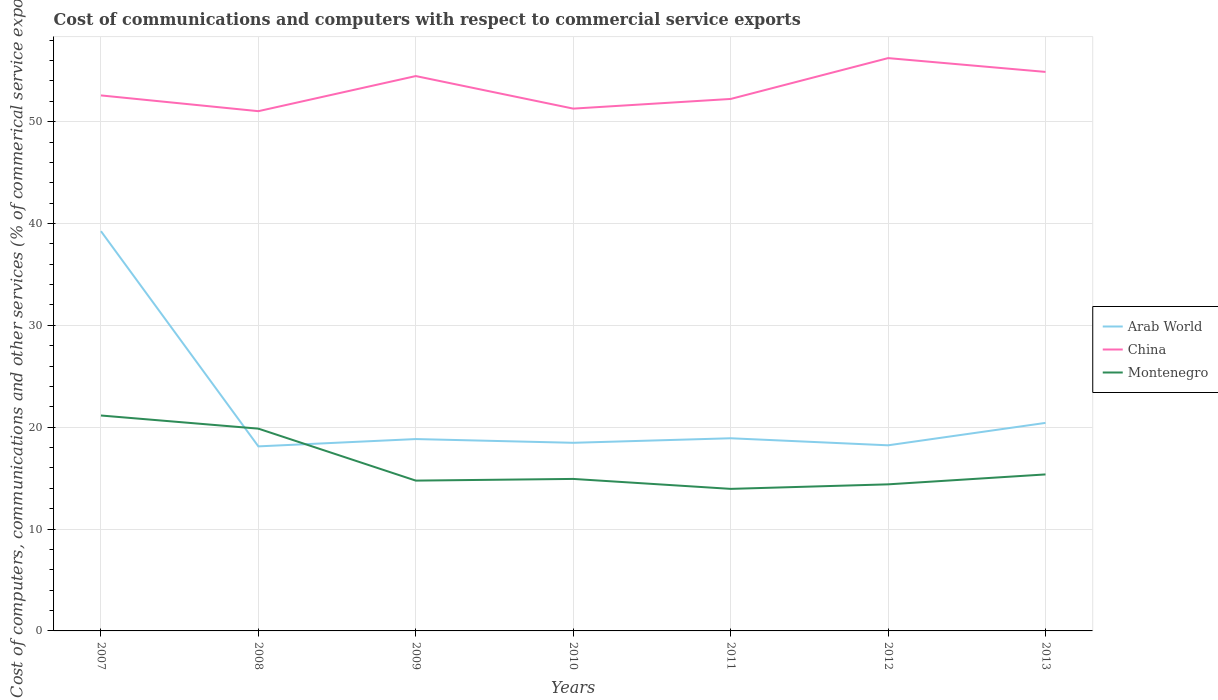Does the line corresponding to Arab World intersect with the line corresponding to China?
Ensure brevity in your answer.  No. Is the number of lines equal to the number of legend labels?
Make the answer very short. Yes. Across all years, what is the maximum cost of communications and computers in Arab World?
Your answer should be compact. 18.12. In which year was the cost of communications and computers in Montenegro maximum?
Your response must be concise. 2011. What is the total cost of communications and computers in China in the graph?
Offer a very short reply. 1.55. What is the difference between the highest and the second highest cost of communications and computers in Montenegro?
Give a very brief answer. 7.2. Is the cost of communications and computers in Montenegro strictly greater than the cost of communications and computers in China over the years?
Offer a terse response. Yes. How many years are there in the graph?
Provide a short and direct response. 7. Does the graph contain grids?
Ensure brevity in your answer.  Yes. Where does the legend appear in the graph?
Ensure brevity in your answer.  Center right. What is the title of the graph?
Give a very brief answer. Cost of communications and computers with respect to commercial service exports. Does "North America" appear as one of the legend labels in the graph?
Ensure brevity in your answer.  No. What is the label or title of the X-axis?
Offer a very short reply. Years. What is the label or title of the Y-axis?
Offer a terse response. Cost of computers, communications and other services (% of commerical service exports). What is the Cost of computers, communications and other services (% of commerical service exports) in Arab World in 2007?
Ensure brevity in your answer.  39.25. What is the Cost of computers, communications and other services (% of commerical service exports) of China in 2007?
Offer a very short reply. 52.58. What is the Cost of computers, communications and other services (% of commerical service exports) in Montenegro in 2007?
Give a very brief answer. 21.15. What is the Cost of computers, communications and other services (% of commerical service exports) of Arab World in 2008?
Provide a short and direct response. 18.12. What is the Cost of computers, communications and other services (% of commerical service exports) of China in 2008?
Your answer should be very brief. 51.03. What is the Cost of computers, communications and other services (% of commerical service exports) in Montenegro in 2008?
Ensure brevity in your answer.  19.86. What is the Cost of computers, communications and other services (% of commerical service exports) in Arab World in 2009?
Your response must be concise. 18.84. What is the Cost of computers, communications and other services (% of commerical service exports) of China in 2009?
Offer a very short reply. 54.48. What is the Cost of computers, communications and other services (% of commerical service exports) of Montenegro in 2009?
Provide a short and direct response. 14.76. What is the Cost of computers, communications and other services (% of commerical service exports) of Arab World in 2010?
Offer a terse response. 18.47. What is the Cost of computers, communications and other services (% of commerical service exports) of China in 2010?
Your answer should be very brief. 51.28. What is the Cost of computers, communications and other services (% of commerical service exports) in Montenegro in 2010?
Your answer should be very brief. 14.92. What is the Cost of computers, communications and other services (% of commerical service exports) in Arab World in 2011?
Provide a short and direct response. 18.92. What is the Cost of computers, communications and other services (% of commerical service exports) of China in 2011?
Offer a very short reply. 52.23. What is the Cost of computers, communications and other services (% of commerical service exports) in Montenegro in 2011?
Give a very brief answer. 13.95. What is the Cost of computers, communications and other services (% of commerical service exports) in Arab World in 2012?
Your response must be concise. 18.22. What is the Cost of computers, communications and other services (% of commerical service exports) in China in 2012?
Provide a succinct answer. 56.24. What is the Cost of computers, communications and other services (% of commerical service exports) in Montenegro in 2012?
Ensure brevity in your answer.  14.39. What is the Cost of computers, communications and other services (% of commerical service exports) in Arab World in 2013?
Your response must be concise. 20.43. What is the Cost of computers, communications and other services (% of commerical service exports) of China in 2013?
Offer a very short reply. 54.89. What is the Cost of computers, communications and other services (% of commerical service exports) in Montenegro in 2013?
Offer a terse response. 15.37. Across all years, what is the maximum Cost of computers, communications and other services (% of commerical service exports) of Arab World?
Offer a terse response. 39.25. Across all years, what is the maximum Cost of computers, communications and other services (% of commerical service exports) in China?
Your answer should be very brief. 56.24. Across all years, what is the maximum Cost of computers, communications and other services (% of commerical service exports) of Montenegro?
Provide a short and direct response. 21.15. Across all years, what is the minimum Cost of computers, communications and other services (% of commerical service exports) of Arab World?
Keep it short and to the point. 18.12. Across all years, what is the minimum Cost of computers, communications and other services (% of commerical service exports) in China?
Your answer should be very brief. 51.03. Across all years, what is the minimum Cost of computers, communications and other services (% of commerical service exports) in Montenegro?
Your response must be concise. 13.95. What is the total Cost of computers, communications and other services (% of commerical service exports) of Arab World in the graph?
Make the answer very short. 152.24. What is the total Cost of computers, communications and other services (% of commerical service exports) of China in the graph?
Your answer should be very brief. 372.72. What is the total Cost of computers, communications and other services (% of commerical service exports) in Montenegro in the graph?
Make the answer very short. 114.4. What is the difference between the Cost of computers, communications and other services (% of commerical service exports) in Arab World in 2007 and that in 2008?
Provide a short and direct response. 21.13. What is the difference between the Cost of computers, communications and other services (% of commerical service exports) in China in 2007 and that in 2008?
Your answer should be compact. 1.55. What is the difference between the Cost of computers, communications and other services (% of commerical service exports) in Montenegro in 2007 and that in 2008?
Your response must be concise. 1.29. What is the difference between the Cost of computers, communications and other services (% of commerical service exports) in Arab World in 2007 and that in 2009?
Offer a very short reply. 20.41. What is the difference between the Cost of computers, communications and other services (% of commerical service exports) in China in 2007 and that in 2009?
Offer a terse response. -1.9. What is the difference between the Cost of computers, communications and other services (% of commerical service exports) in Montenegro in 2007 and that in 2009?
Your answer should be compact. 6.39. What is the difference between the Cost of computers, communications and other services (% of commerical service exports) of Arab World in 2007 and that in 2010?
Make the answer very short. 20.78. What is the difference between the Cost of computers, communications and other services (% of commerical service exports) in China in 2007 and that in 2010?
Your answer should be very brief. 1.3. What is the difference between the Cost of computers, communications and other services (% of commerical service exports) of Montenegro in 2007 and that in 2010?
Offer a very short reply. 6.23. What is the difference between the Cost of computers, communications and other services (% of commerical service exports) of Arab World in 2007 and that in 2011?
Ensure brevity in your answer.  20.33. What is the difference between the Cost of computers, communications and other services (% of commerical service exports) in China in 2007 and that in 2011?
Offer a terse response. 0.35. What is the difference between the Cost of computers, communications and other services (% of commerical service exports) in Montenegro in 2007 and that in 2011?
Offer a very short reply. 7.2. What is the difference between the Cost of computers, communications and other services (% of commerical service exports) of Arab World in 2007 and that in 2012?
Make the answer very short. 21.03. What is the difference between the Cost of computers, communications and other services (% of commerical service exports) of China in 2007 and that in 2012?
Provide a short and direct response. -3.66. What is the difference between the Cost of computers, communications and other services (% of commerical service exports) in Montenegro in 2007 and that in 2012?
Provide a succinct answer. 6.76. What is the difference between the Cost of computers, communications and other services (% of commerical service exports) in Arab World in 2007 and that in 2013?
Your answer should be very brief. 18.82. What is the difference between the Cost of computers, communications and other services (% of commerical service exports) in China in 2007 and that in 2013?
Keep it short and to the point. -2.31. What is the difference between the Cost of computers, communications and other services (% of commerical service exports) in Montenegro in 2007 and that in 2013?
Offer a terse response. 5.78. What is the difference between the Cost of computers, communications and other services (% of commerical service exports) in Arab World in 2008 and that in 2009?
Offer a terse response. -0.72. What is the difference between the Cost of computers, communications and other services (% of commerical service exports) in China in 2008 and that in 2009?
Offer a very short reply. -3.45. What is the difference between the Cost of computers, communications and other services (% of commerical service exports) in Montenegro in 2008 and that in 2009?
Your answer should be compact. 5.1. What is the difference between the Cost of computers, communications and other services (% of commerical service exports) of Arab World in 2008 and that in 2010?
Your answer should be compact. -0.35. What is the difference between the Cost of computers, communications and other services (% of commerical service exports) in China in 2008 and that in 2010?
Offer a terse response. -0.25. What is the difference between the Cost of computers, communications and other services (% of commerical service exports) in Montenegro in 2008 and that in 2010?
Provide a succinct answer. 4.94. What is the difference between the Cost of computers, communications and other services (% of commerical service exports) of Arab World in 2008 and that in 2011?
Give a very brief answer. -0.8. What is the difference between the Cost of computers, communications and other services (% of commerical service exports) in China in 2008 and that in 2011?
Offer a very short reply. -1.2. What is the difference between the Cost of computers, communications and other services (% of commerical service exports) in Montenegro in 2008 and that in 2011?
Your answer should be very brief. 5.91. What is the difference between the Cost of computers, communications and other services (% of commerical service exports) of Arab World in 2008 and that in 2012?
Keep it short and to the point. -0.11. What is the difference between the Cost of computers, communications and other services (% of commerical service exports) of China in 2008 and that in 2012?
Make the answer very short. -5.21. What is the difference between the Cost of computers, communications and other services (% of commerical service exports) in Montenegro in 2008 and that in 2012?
Provide a succinct answer. 5.47. What is the difference between the Cost of computers, communications and other services (% of commerical service exports) in Arab World in 2008 and that in 2013?
Offer a very short reply. -2.31. What is the difference between the Cost of computers, communications and other services (% of commerical service exports) in China in 2008 and that in 2013?
Your answer should be compact. -3.85. What is the difference between the Cost of computers, communications and other services (% of commerical service exports) in Montenegro in 2008 and that in 2013?
Your answer should be compact. 4.49. What is the difference between the Cost of computers, communications and other services (% of commerical service exports) of Arab World in 2009 and that in 2010?
Give a very brief answer. 0.37. What is the difference between the Cost of computers, communications and other services (% of commerical service exports) in China in 2009 and that in 2010?
Ensure brevity in your answer.  3.2. What is the difference between the Cost of computers, communications and other services (% of commerical service exports) of Montenegro in 2009 and that in 2010?
Your answer should be compact. -0.17. What is the difference between the Cost of computers, communications and other services (% of commerical service exports) in Arab World in 2009 and that in 2011?
Keep it short and to the point. -0.08. What is the difference between the Cost of computers, communications and other services (% of commerical service exports) of China in 2009 and that in 2011?
Keep it short and to the point. 2.25. What is the difference between the Cost of computers, communications and other services (% of commerical service exports) in Montenegro in 2009 and that in 2011?
Provide a short and direct response. 0.81. What is the difference between the Cost of computers, communications and other services (% of commerical service exports) of Arab World in 2009 and that in 2012?
Ensure brevity in your answer.  0.61. What is the difference between the Cost of computers, communications and other services (% of commerical service exports) of China in 2009 and that in 2012?
Your answer should be compact. -1.76. What is the difference between the Cost of computers, communications and other services (% of commerical service exports) of Montenegro in 2009 and that in 2012?
Ensure brevity in your answer.  0.37. What is the difference between the Cost of computers, communications and other services (% of commerical service exports) in Arab World in 2009 and that in 2013?
Provide a succinct answer. -1.59. What is the difference between the Cost of computers, communications and other services (% of commerical service exports) in China in 2009 and that in 2013?
Provide a short and direct response. -0.41. What is the difference between the Cost of computers, communications and other services (% of commerical service exports) in Montenegro in 2009 and that in 2013?
Provide a succinct answer. -0.61. What is the difference between the Cost of computers, communications and other services (% of commerical service exports) of Arab World in 2010 and that in 2011?
Make the answer very short. -0.44. What is the difference between the Cost of computers, communications and other services (% of commerical service exports) in China in 2010 and that in 2011?
Keep it short and to the point. -0.95. What is the difference between the Cost of computers, communications and other services (% of commerical service exports) in Montenegro in 2010 and that in 2011?
Give a very brief answer. 0.98. What is the difference between the Cost of computers, communications and other services (% of commerical service exports) of Arab World in 2010 and that in 2012?
Offer a very short reply. 0.25. What is the difference between the Cost of computers, communications and other services (% of commerical service exports) in China in 2010 and that in 2012?
Your answer should be compact. -4.96. What is the difference between the Cost of computers, communications and other services (% of commerical service exports) of Montenegro in 2010 and that in 2012?
Your answer should be very brief. 0.53. What is the difference between the Cost of computers, communications and other services (% of commerical service exports) in Arab World in 2010 and that in 2013?
Your answer should be compact. -1.95. What is the difference between the Cost of computers, communications and other services (% of commerical service exports) in China in 2010 and that in 2013?
Offer a very short reply. -3.6. What is the difference between the Cost of computers, communications and other services (% of commerical service exports) in Montenegro in 2010 and that in 2013?
Your answer should be compact. -0.44. What is the difference between the Cost of computers, communications and other services (% of commerical service exports) in Arab World in 2011 and that in 2012?
Offer a very short reply. 0.69. What is the difference between the Cost of computers, communications and other services (% of commerical service exports) of China in 2011 and that in 2012?
Provide a succinct answer. -4.01. What is the difference between the Cost of computers, communications and other services (% of commerical service exports) in Montenegro in 2011 and that in 2012?
Your response must be concise. -0.44. What is the difference between the Cost of computers, communications and other services (% of commerical service exports) of Arab World in 2011 and that in 2013?
Offer a very short reply. -1.51. What is the difference between the Cost of computers, communications and other services (% of commerical service exports) in China in 2011 and that in 2013?
Ensure brevity in your answer.  -2.65. What is the difference between the Cost of computers, communications and other services (% of commerical service exports) in Montenegro in 2011 and that in 2013?
Keep it short and to the point. -1.42. What is the difference between the Cost of computers, communications and other services (% of commerical service exports) of Arab World in 2012 and that in 2013?
Your answer should be compact. -2.2. What is the difference between the Cost of computers, communications and other services (% of commerical service exports) in China in 2012 and that in 2013?
Your answer should be compact. 1.35. What is the difference between the Cost of computers, communications and other services (% of commerical service exports) in Montenegro in 2012 and that in 2013?
Ensure brevity in your answer.  -0.97. What is the difference between the Cost of computers, communications and other services (% of commerical service exports) in Arab World in 2007 and the Cost of computers, communications and other services (% of commerical service exports) in China in 2008?
Offer a terse response. -11.78. What is the difference between the Cost of computers, communications and other services (% of commerical service exports) in Arab World in 2007 and the Cost of computers, communications and other services (% of commerical service exports) in Montenegro in 2008?
Your answer should be compact. 19.39. What is the difference between the Cost of computers, communications and other services (% of commerical service exports) of China in 2007 and the Cost of computers, communications and other services (% of commerical service exports) of Montenegro in 2008?
Offer a terse response. 32.72. What is the difference between the Cost of computers, communications and other services (% of commerical service exports) of Arab World in 2007 and the Cost of computers, communications and other services (% of commerical service exports) of China in 2009?
Your answer should be compact. -15.23. What is the difference between the Cost of computers, communications and other services (% of commerical service exports) of Arab World in 2007 and the Cost of computers, communications and other services (% of commerical service exports) of Montenegro in 2009?
Your answer should be very brief. 24.49. What is the difference between the Cost of computers, communications and other services (% of commerical service exports) in China in 2007 and the Cost of computers, communications and other services (% of commerical service exports) in Montenegro in 2009?
Your response must be concise. 37.82. What is the difference between the Cost of computers, communications and other services (% of commerical service exports) of Arab World in 2007 and the Cost of computers, communications and other services (% of commerical service exports) of China in 2010?
Offer a very short reply. -12.03. What is the difference between the Cost of computers, communications and other services (% of commerical service exports) of Arab World in 2007 and the Cost of computers, communications and other services (% of commerical service exports) of Montenegro in 2010?
Give a very brief answer. 24.33. What is the difference between the Cost of computers, communications and other services (% of commerical service exports) of China in 2007 and the Cost of computers, communications and other services (% of commerical service exports) of Montenegro in 2010?
Provide a short and direct response. 37.65. What is the difference between the Cost of computers, communications and other services (% of commerical service exports) of Arab World in 2007 and the Cost of computers, communications and other services (% of commerical service exports) of China in 2011?
Provide a succinct answer. -12.98. What is the difference between the Cost of computers, communications and other services (% of commerical service exports) of Arab World in 2007 and the Cost of computers, communications and other services (% of commerical service exports) of Montenegro in 2011?
Give a very brief answer. 25.3. What is the difference between the Cost of computers, communications and other services (% of commerical service exports) in China in 2007 and the Cost of computers, communications and other services (% of commerical service exports) in Montenegro in 2011?
Your answer should be very brief. 38.63. What is the difference between the Cost of computers, communications and other services (% of commerical service exports) in Arab World in 2007 and the Cost of computers, communications and other services (% of commerical service exports) in China in 2012?
Ensure brevity in your answer.  -16.99. What is the difference between the Cost of computers, communications and other services (% of commerical service exports) in Arab World in 2007 and the Cost of computers, communications and other services (% of commerical service exports) in Montenegro in 2012?
Provide a succinct answer. 24.86. What is the difference between the Cost of computers, communications and other services (% of commerical service exports) of China in 2007 and the Cost of computers, communications and other services (% of commerical service exports) of Montenegro in 2012?
Keep it short and to the point. 38.19. What is the difference between the Cost of computers, communications and other services (% of commerical service exports) in Arab World in 2007 and the Cost of computers, communications and other services (% of commerical service exports) in China in 2013?
Your answer should be very brief. -15.64. What is the difference between the Cost of computers, communications and other services (% of commerical service exports) of Arab World in 2007 and the Cost of computers, communications and other services (% of commerical service exports) of Montenegro in 2013?
Ensure brevity in your answer.  23.88. What is the difference between the Cost of computers, communications and other services (% of commerical service exports) in China in 2007 and the Cost of computers, communications and other services (% of commerical service exports) in Montenegro in 2013?
Provide a succinct answer. 37.21. What is the difference between the Cost of computers, communications and other services (% of commerical service exports) in Arab World in 2008 and the Cost of computers, communications and other services (% of commerical service exports) in China in 2009?
Offer a terse response. -36.36. What is the difference between the Cost of computers, communications and other services (% of commerical service exports) in Arab World in 2008 and the Cost of computers, communications and other services (% of commerical service exports) in Montenegro in 2009?
Make the answer very short. 3.36. What is the difference between the Cost of computers, communications and other services (% of commerical service exports) of China in 2008 and the Cost of computers, communications and other services (% of commerical service exports) of Montenegro in 2009?
Keep it short and to the point. 36.27. What is the difference between the Cost of computers, communications and other services (% of commerical service exports) of Arab World in 2008 and the Cost of computers, communications and other services (% of commerical service exports) of China in 2010?
Offer a very short reply. -33.16. What is the difference between the Cost of computers, communications and other services (% of commerical service exports) in Arab World in 2008 and the Cost of computers, communications and other services (% of commerical service exports) in Montenegro in 2010?
Give a very brief answer. 3.2. What is the difference between the Cost of computers, communications and other services (% of commerical service exports) of China in 2008 and the Cost of computers, communications and other services (% of commerical service exports) of Montenegro in 2010?
Provide a short and direct response. 36.11. What is the difference between the Cost of computers, communications and other services (% of commerical service exports) of Arab World in 2008 and the Cost of computers, communications and other services (% of commerical service exports) of China in 2011?
Your answer should be very brief. -34.11. What is the difference between the Cost of computers, communications and other services (% of commerical service exports) of Arab World in 2008 and the Cost of computers, communications and other services (% of commerical service exports) of Montenegro in 2011?
Your response must be concise. 4.17. What is the difference between the Cost of computers, communications and other services (% of commerical service exports) of China in 2008 and the Cost of computers, communications and other services (% of commerical service exports) of Montenegro in 2011?
Your response must be concise. 37.08. What is the difference between the Cost of computers, communications and other services (% of commerical service exports) of Arab World in 2008 and the Cost of computers, communications and other services (% of commerical service exports) of China in 2012?
Keep it short and to the point. -38.12. What is the difference between the Cost of computers, communications and other services (% of commerical service exports) in Arab World in 2008 and the Cost of computers, communications and other services (% of commerical service exports) in Montenegro in 2012?
Your answer should be very brief. 3.73. What is the difference between the Cost of computers, communications and other services (% of commerical service exports) of China in 2008 and the Cost of computers, communications and other services (% of commerical service exports) of Montenegro in 2012?
Your answer should be compact. 36.64. What is the difference between the Cost of computers, communications and other services (% of commerical service exports) of Arab World in 2008 and the Cost of computers, communications and other services (% of commerical service exports) of China in 2013?
Provide a short and direct response. -36.77. What is the difference between the Cost of computers, communications and other services (% of commerical service exports) of Arab World in 2008 and the Cost of computers, communications and other services (% of commerical service exports) of Montenegro in 2013?
Your answer should be very brief. 2.75. What is the difference between the Cost of computers, communications and other services (% of commerical service exports) of China in 2008 and the Cost of computers, communications and other services (% of commerical service exports) of Montenegro in 2013?
Offer a terse response. 35.66. What is the difference between the Cost of computers, communications and other services (% of commerical service exports) of Arab World in 2009 and the Cost of computers, communications and other services (% of commerical service exports) of China in 2010?
Ensure brevity in your answer.  -32.44. What is the difference between the Cost of computers, communications and other services (% of commerical service exports) of Arab World in 2009 and the Cost of computers, communications and other services (% of commerical service exports) of Montenegro in 2010?
Your answer should be compact. 3.91. What is the difference between the Cost of computers, communications and other services (% of commerical service exports) in China in 2009 and the Cost of computers, communications and other services (% of commerical service exports) in Montenegro in 2010?
Offer a very short reply. 39.55. What is the difference between the Cost of computers, communications and other services (% of commerical service exports) of Arab World in 2009 and the Cost of computers, communications and other services (% of commerical service exports) of China in 2011?
Your answer should be very brief. -33.39. What is the difference between the Cost of computers, communications and other services (% of commerical service exports) in Arab World in 2009 and the Cost of computers, communications and other services (% of commerical service exports) in Montenegro in 2011?
Provide a succinct answer. 4.89. What is the difference between the Cost of computers, communications and other services (% of commerical service exports) of China in 2009 and the Cost of computers, communications and other services (% of commerical service exports) of Montenegro in 2011?
Make the answer very short. 40.53. What is the difference between the Cost of computers, communications and other services (% of commerical service exports) in Arab World in 2009 and the Cost of computers, communications and other services (% of commerical service exports) in China in 2012?
Provide a succinct answer. -37.4. What is the difference between the Cost of computers, communications and other services (% of commerical service exports) in Arab World in 2009 and the Cost of computers, communications and other services (% of commerical service exports) in Montenegro in 2012?
Ensure brevity in your answer.  4.45. What is the difference between the Cost of computers, communications and other services (% of commerical service exports) of China in 2009 and the Cost of computers, communications and other services (% of commerical service exports) of Montenegro in 2012?
Offer a terse response. 40.09. What is the difference between the Cost of computers, communications and other services (% of commerical service exports) in Arab World in 2009 and the Cost of computers, communications and other services (% of commerical service exports) in China in 2013?
Offer a very short reply. -36.05. What is the difference between the Cost of computers, communications and other services (% of commerical service exports) of Arab World in 2009 and the Cost of computers, communications and other services (% of commerical service exports) of Montenegro in 2013?
Provide a succinct answer. 3.47. What is the difference between the Cost of computers, communications and other services (% of commerical service exports) of China in 2009 and the Cost of computers, communications and other services (% of commerical service exports) of Montenegro in 2013?
Offer a very short reply. 39.11. What is the difference between the Cost of computers, communications and other services (% of commerical service exports) of Arab World in 2010 and the Cost of computers, communications and other services (% of commerical service exports) of China in 2011?
Provide a succinct answer. -33.76. What is the difference between the Cost of computers, communications and other services (% of commerical service exports) of Arab World in 2010 and the Cost of computers, communications and other services (% of commerical service exports) of Montenegro in 2011?
Your answer should be compact. 4.52. What is the difference between the Cost of computers, communications and other services (% of commerical service exports) in China in 2010 and the Cost of computers, communications and other services (% of commerical service exports) in Montenegro in 2011?
Give a very brief answer. 37.33. What is the difference between the Cost of computers, communications and other services (% of commerical service exports) in Arab World in 2010 and the Cost of computers, communications and other services (% of commerical service exports) in China in 2012?
Provide a short and direct response. -37.77. What is the difference between the Cost of computers, communications and other services (% of commerical service exports) in Arab World in 2010 and the Cost of computers, communications and other services (% of commerical service exports) in Montenegro in 2012?
Offer a very short reply. 4.08. What is the difference between the Cost of computers, communications and other services (% of commerical service exports) in China in 2010 and the Cost of computers, communications and other services (% of commerical service exports) in Montenegro in 2012?
Your response must be concise. 36.89. What is the difference between the Cost of computers, communications and other services (% of commerical service exports) of Arab World in 2010 and the Cost of computers, communications and other services (% of commerical service exports) of China in 2013?
Your response must be concise. -36.41. What is the difference between the Cost of computers, communications and other services (% of commerical service exports) in Arab World in 2010 and the Cost of computers, communications and other services (% of commerical service exports) in Montenegro in 2013?
Give a very brief answer. 3.1. What is the difference between the Cost of computers, communications and other services (% of commerical service exports) in China in 2010 and the Cost of computers, communications and other services (% of commerical service exports) in Montenegro in 2013?
Offer a terse response. 35.92. What is the difference between the Cost of computers, communications and other services (% of commerical service exports) in Arab World in 2011 and the Cost of computers, communications and other services (% of commerical service exports) in China in 2012?
Give a very brief answer. -37.32. What is the difference between the Cost of computers, communications and other services (% of commerical service exports) of Arab World in 2011 and the Cost of computers, communications and other services (% of commerical service exports) of Montenegro in 2012?
Your answer should be compact. 4.52. What is the difference between the Cost of computers, communications and other services (% of commerical service exports) in China in 2011 and the Cost of computers, communications and other services (% of commerical service exports) in Montenegro in 2012?
Keep it short and to the point. 37.84. What is the difference between the Cost of computers, communications and other services (% of commerical service exports) in Arab World in 2011 and the Cost of computers, communications and other services (% of commerical service exports) in China in 2013?
Give a very brief answer. -35.97. What is the difference between the Cost of computers, communications and other services (% of commerical service exports) of Arab World in 2011 and the Cost of computers, communications and other services (% of commerical service exports) of Montenegro in 2013?
Make the answer very short. 3.55. What is the difference between the Cost of computers, communications and other services (% of commerical service exports) of China in 2011 and the Cost of computers, communications and other services (% of commerical service exports) of Montenegro in 2013?
Make the answer very short. 36.86. What is the difference between the Cost of computers, communications and other services (% of commerical service exports) in Arab World in 2012 and the Cost of computers, communications and other services (% of commerical service exports) in China in 2013?
Ensure brevity in your answer.  -36.66. What is the difference between the Cost of computers, communications and other services (% of commerical service exports) of Arab World in 2012 and the Cost of computers, communications and other services (% of commerical service exports) of Montenegro in 2013?
Ensure brevity in your answer.  2.86. What is the difference between the Cost of computers, communications and other services (% of commerical service exports) in China in 2012 and the Cost of computers, communications and other services (% of commerical service exports) in Montenegro in 2013?
Your answer should be compact. 40.87. What is the average Cost of computers, communications and other services (% of commerical service exports) of Arab World per year?
Your response must be concise. 21.75. What is the average Cost of computers, communications and other services (% of commerical service exports) of China per year?
Your answer should be very brief. 53.25. What is the average Cost of computers, communications and other services (% of commerical service exports) in Montenegro per year?
Offer a very short reply. 16.34. In the year 2007, what is the difference between the Cost of computers, communications and other services (% of commerical service exports) in Arab World and Cost of computers, communications and other services (% of commerical service exports) in China?
Give a very brief answer. -13.33. In the year 2007, what is the difference between the Cost of computers, communications and other services (% of commerical service exports) of Arab World and Cost of computers, communications and other services (% of commerical service exports) of Montenegro?
Provide a short and direct response. 18.1. In the year 2007, what is the difference between the Cost of computers, communications and other services (% of commerical service exports) of China and Cost of computers, communications and other services (% of commerical service exports) of Montenegro?
Your response must be concise. 31.43. In the year 2008, what is the difference between the Cost of computers, communications and other services (% of commerical service exports) of Arab World and Cost of computers, communications and other services (% of commerical service exports) of China?
Your response must be concise. -32.91. In the year 2008, what is the difference between the Cost of computers, communications and other services (% of commerical service exports) of Arab World and Cost of computers, communications and other services (% of commerical service exports) of Montenegro?
Provide a succinct answer. -1.74. In the year 2008, what is the difference between the Cost of computers, communications and other services (% of commerical service exports) of China and Cost of computers, communications and other services (% of commerical service exports) of Montenegro?
Provide a short and direct response. 31.17. In the year 2009, what is the difference between the Cost of computers, communications and other services (% of commerical service exports) of Arab World and Cost of computers, communications and other services (% of commerical service exports) of China?
Your response must be concise. -35.64. In the year 2009, what is the difference between the Cost of computers, communications and other services (% of commerical service exports) in Arab World and Cost of computers, communications and other services (% of commerical service exports) in Montenegro?
Offer a very short reply. 4.08. In the year 2009, what is the difference between the Cost of computers, communications and other services (% of commerical service exports) of China and Cost of computers, communications and other services (% of commerical service exports) of Montenegro?
Your response must be concise. 39.72. In the year 2010, what is the difference between the Cost of computers, communications and other services (% of commerical service exports) of Arab World and Cost of computers, communications and other services (% of commerical service exports) of China?
Give a very brief answer. -32.81. In the year 2010, what is the difference between the Cost of computers, communications and other services (% of commerical service exports) of Arab World and Cost of computers, communications and other services (% of commerical service exports) of Montenegro?
Offer a very short reply. 3.55. In the year 2010, what is the difference between the Cost of computers, communications and other services (% of commerical service exports) in China and Cost of computers, communications and other services (% of commerical service exports) in Montenegro?
Ensure brevity in your answer.  36.36. In the year 2011, what is the difference between the Cost of computers, communications and other services (% of commerical service exports) of Arab World and Cost of computers, communications and other services (% of commerical service exports) of China?
Offer a very short reply. -33.31. In the year 2011, what is the difference between the Cost of computers, communications and other services (% of commerical service exports) of Arab World and Cost of computers, communications and other services (% of commerical service exports) of Montenegro?
Your answer should be very brief. 4.97. In the year 2011, what is the difference between the Cost of computers, communications and other services (% of commerical service exports) in China and Cost of computers, communications and other services (% of commerical service exports) in Montenegro?
Provide a succinct answer. 38.28. In the year 2012, what is the difference between the Cost of computers, communications and other services (% of commerical service exports) of Arab World and Cost of computers, communications and other services (% of commerical service exports) of China?
Your answer should be compact. -38.02. In the year 2012, what is the difference between the Cost of computers, communications and other services (% of commerical service exports) of Arab World and Cost of computers, communications and other services (% of commerical service exports) of Montenegro?
Make the answer very short. 3.83. In the year 2012, what is the difference between the Cost of computers, communications and other services (% of commerical service exports) in China and Cost of computers, communications and other services (% of commerical service exports) in Montenegro?
Give a very brief answer. 41.85. In the year 2013, what is the difference between the Cost of computers, communications and other services (% of commerical service exports) in Arab World and Cost of computers, communications and other services (% of commerical service exports) in China?
Provide a succinct answer. -34.46. In the year 2013, what is the difference between the Cost of computers, communications and other services (% of commerical service exports) of Arab World and Cost of computers, communications and other services (% of commerical service exports) of Montenegro?
Make the answer very short. 5.06. In the year 2013, what is the difference between the Cost of computers, communications and other services (% of commerical service exports) in China and Cost of computers, communications and other services (% of commerical service exports) in Montenegro?
Your answer should be very brief. 39.52. What is the ratio of the Cost of computers, communications and other services (% of commerical service exports) of Arab World in 2007 to that in 2008?
Give a very brief answer. 2.17. What is the ratio of the Cost of computers, communications and other services (% of commerical service exports) in China in 2007 to that in 2008?
Provide a short and direct response. 1.03. What is the ratio of the Cost of computers, communications and other services (% of commerical service exports) in Montenegro in 2007 to that in 2008?
Offer a very short reply. 1.06. What is the ratio of the Cost of computers, communications and other services (% of commerical service exports) in Arab World in 2007 to that in 2009?
Your response must be concise. 2.08. What is the ratio of the Cost of computers, communications and other services (% of commerical service exports) in China in 2007 to that in 2009?
Offer a terse response. 0.97. What is the ratio of the Cost of computers, communications and other services (% of commerical service exports) in Montenegro in 2007 to that in 2009?
Give a very brief answer. 1.43. What is the ratio of the Cost of computers, communications and other services (% of commerical service exports) of Arab World in 2007 to that in 2010?
Ensure brevity in your answer.  2.12. What is the ratio of the Cost of computers, communications and other services (% of commerical service exports) of China in 2007 to that in 2010?
Offer a terse response. 1.03. What is the ratio of the Cost of computers, communications and other services (% of commerical service exports) of Montenegro in 2007 to that in 2010?
Give a very brief answer. 1.42. What is the ratio of the Cost of computers, communications and other services (% of commerical service exports) in Arab World in 2007 to that in 2011?
Offer a very short reply. 2.07. What is the ratio of the Cost of computers, communications and other services (% of commerical service exports) of China in 2007 to that in 2011?
Offer a terse response. 1.01. What is the ratio of the Cost of computers, communications and other services (% of commerical service exports) of Montenegro in 2007 to that in 2011?
Your response must be concise. 1.52. What is the ratio of the Cost of computers, communications and other services (% of commerical service exports) of Arab World in 2007 to that in 2012?
Your answer should be very brief. 2.15. What is the ratio of the Cost of computers, communications and other services (% of commerical service exports) of China in 2007 to that in 2012?
Provide a succinct answer. 0.93. What is the ratio of the Cost of computers, communications and other services (% of commerical service exports) in Montenegro in 2007 to that in 2012?
Offer a very short reply. 1.47. What is the ratio of the Cost of computers, communications and other services (% of commerical service exports) of Arab World in 2007 to that in 2013?
Give a very brief answer. 1.92. What is the ratio of the Cost of computers, communications and other services (% of commerical service exports) of China in 2007 to that in 2013?
Offer a very short reply. 0.96. What is the ratio of the Cost of computers, communications and other services (% of commerical service exports) in Montenegro in 2007 to that in 2013?
Your answer should be very brief. 1.38. What is the ratio of the Cost of computers, communications and other services (% of commerical service exports) in Arab World in 2008 to that in 2009?
Offer a very short reply. 0.96. What is the ratio of the Cost of computers, communications and other services (% of commerical service exports) in China in 2008 to that in 2009?
Provide a succinct answer. 0.94. What is the ratio of the Cost of computers, communications and other services (% of commerical service exports) in Montenegro in 2008 to that in 2009?
Give a very brief answer. 1.35. What is the ratio of the Cost of computers, communications and other services (% of commerical service exports) in Arab World in 2008 to that in 2010?
Provide a succinct answer. 0.98. What is the ratio of the Cost of computers, communications and other services (% of commerical service exports) in Montenegro in 2008 to that in 2010?
Provide a short and direct response. 1.33. What is the ratio of the Cost of computers, communications and other services (% of commerical service exports) of Arab World in 2008 to that in 2011?
Your response must be concise. 0.96. What is the ratio of the Cost of computers, communications and other services (% of commerical service exports) of Montenegro in 2008 to that in 2011?
Provide a short and direct response. 1.42. What is the ratio of the Cost of computers, communications and other services (% of commerical service exports) in China in 2008 to that in 2012?
Give a very brief answer. 0.91. What is the ratio of the Cost of computers, communications and other services (% of commerical service exports) in Montenegro in 2008 to that in 2012?
Provide a succinct answer. 1.38. What is the ratio of the Cost of computers, communications and other services (% of commerical service exports) in Arab World in 2008 to that in 2013?
Provide a succinct answer. 0.89. What is the ratio of the Cost of computers, communications and other services (% of commerical service exports) of China in 2008 to that in 2013?
Ensure brevity in your answer.  0.93. What is the ratio of the Cost of computers, communications and other services (% of commerical service exports) in Montenegro in 2008 to that in 2013?
Offer a very short reply. 1.29. What is the ratio of the Cost of computers, communications and other services (% of commerical service exports) of Arab World in 2009 to that in 2010?
Provide a short and direct response. 1.02. What is the ratio of the Cost of computers, communications and other services (% of commerical service exports) in China in 2009 to that in 2010?
Keep it short and to the point. 1.06. What is the ratio of the Cost of computers, communications and other services (% of commerical service exports) in Montenegro in 2009 to that in 2010?
Provide a succinct answer. 0.99. What is the ratio of the Cost of computers, communications and other services (% of commerical service exports) of China in 2009 to that in 2011?
Your answer should be compact. 1.04. What is the ratio of the Cost of computers, communications and other services (% of commerical service exports) of Montenegro in 2009 to that in 2011?
Your answer should be compact. 1.06. What is the ratio of the Cost of computers, communications and other services (% of commerical service exports) of Arab World in 2009 to that in 2012?
Your response must be concise. 1.03. What is the ratio of the Cost of computers, communications and other services (% of commerical service exports) in China in 2009 to that in 2012?
Your answer should be very brief. 0.97. What is the ratio of the Cost of computers, communications and other services (% of commerical service exports) in Montenegro in 2009 to that in 2012?
Your answer should be very brief. 1.03. What is the ratio of the Cost of computers, communications and other services (% of commerical service exports) in Arab World in 2009 to that in 2013?
Keep it short and to the point. 0.92. What is the ratio of the Cost of computers, communications and other services (% of commerical service exports) of Montenegro in 2009 to that in 2013?
Provide a succinct answer. 0.96. What is the ratio of the Cost of computers, communications and other services (% of commerical service exports) of Arab World in 2010 to that in 2011?
Offer a very short reply. 0.98. What is the ratio of the Cost of computers, communications and other services (% of commerical service exports) in China in 2010 to that in 2011?
Ensure brevity in your answer.  0.98. What is the ratio of the Cost of computers, communications and other services (% of commerical service exports) of Montenegro in 2010 to that in 2011?
Give a very brief answer. 1.07. What is the ratio of the Cost of computers, communications and other services (% of commerical service exports) in Arab World in 2010 to that in 2012?
Your response must be concise. 1.01. What is the ratio of the Cost of computers, communications and other services (% of commerical service exports) in China in 2010 to that in 2012?
Provide a short and direct response. 0.91. What is the ratio of the Cost of computers, communications and other services (% of commerical service exports) in Montenegro in 2010 to that in 2012?
Provide a succinct answer. 1.04. What is the ratio of the Cost of computers, communications and other services (% of commerical service exports) of Arab World in 2010 to that in 2013?
Offer a terse response. 0.9. What is the ratio of the Cost of computers, communications and other services (% of commerical service exports) in China in 2010 to that in 2013?
Your answer should be very brief. 0.93. What is the ratio of the Cost of computers, communications and other services (% of commerical service exports) in Montenegro in 2010 to that in 2013?
Ensure brevity in your answer.  0.97. What is the ratio of the Cost of computers, communications and other services (% of commerical service exports) of Arab World in 2011 to that in 2012?
Provide a succinct answer. 1.04. What is the ratio of the Cost of computers, communications and other services (% of commerical service exports) of China in 2011 to that in 2012?
Provide a short and direct response. 0.93. What is the ratio of the Cost of computers, communications and other services (% of commerical service exports) of Montenegro in 2011 to that in 2012?
Offer a very short reply. 0.97. What is the ratio of the Cost of computers, communications and other services (% of commerical service exports) in Arab World in 2011 to that in 2013?
Give a very brief answer. 0.93. What is the ratio of the Cost of computers, communications and other services (% of commerical service exports) in China in 2011 to that in 2013?
Your answer should be compact. 0.95. What is the ratio of the Cost of computers, communications and other services (% of commerical service exports) in Montenegro in 2011 to that in 2013?
Ensure brevity in your answer.  0.91. What is the ratio of the Cost of computers, communications and other services (% of commerical service exports) in Arab World in 2012 to that in 2013?
Make the answer very short. 0.89. What is the ratio of the Cost of computers, communications and other services (% of commerical service exports) of China in 2012 to that in 2013?
Provide a short and direct response. 1.02. What is the ratio of the Cost of computers, communications and other services (% of commerical service exports) in Montenegro in 2012 to that in 2013?
Offer a terse response. 0.94. What is the difference between the highest and the second highest Cost of computers, communications and other services (% of commerical service exports) in Arab World?
Your response must be concise. 18.82. What is the difference between the highest and the second highest Cost of computers, communications and other services (% of commerical service exports) in China?
Give a very brief answer. 1.35. What is the difference between the highest and the second highest Cost of computers, communications and other services (% of commerical service exports) of Montenegro?
Offer a terse response. 1.29. What is the difference between the highest and the lowest Cost of computers, communications and other services (% of commerical service exports) in Arab World?
Your response must be concise. 21.13. What is the difference between the highest and the lowest Cost of computers, communications and other services (% of commerical service exports) in China?
Ensure brevity in your answer.  5.21. What is the difference between the highest and the lowest Cost of computers, communications and other services (% of commerical service exports) of Montenegro?
Keep it short and to the point. 7.2. 